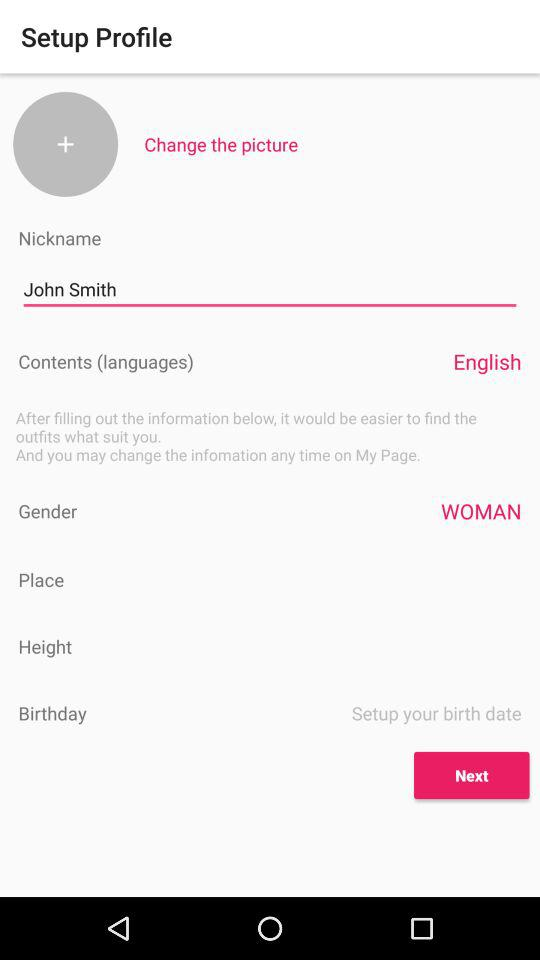What is the gender of the user? The gender of the user is woman. 